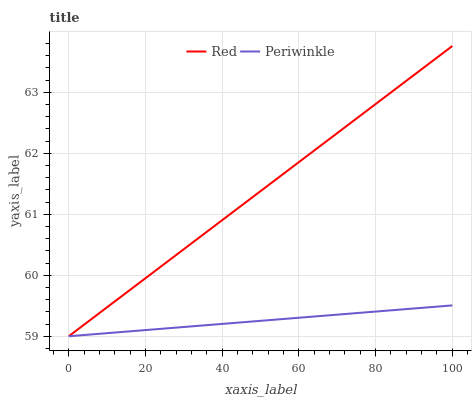Does Periwinkle have the minimum area under the curve?
Answer yes or no. Yes. Does Red have the maximum area under the curve?
Answer yes or no. Yes. Does Red have the minimum area under the curve?
Answer yes or no. No. Is Red the smoothest?
Answer yes or no. Yes. Is Periwinkle the roughest?
Answer yes or no. Yes. Is Red the roughest?
Answer yes or no. No. Does Periwinkle have the lowest value?
Answer yes or no. Yes. Does Red have the highest value?
Answer yes or no. Yes. Does Red intersect Periwinkle?
Answer yes or no. Yes. Is Red less than Periwinkle?
Answer yes or no. No. Is Red greater than Periwinkle?
Answer yes or no. No. 